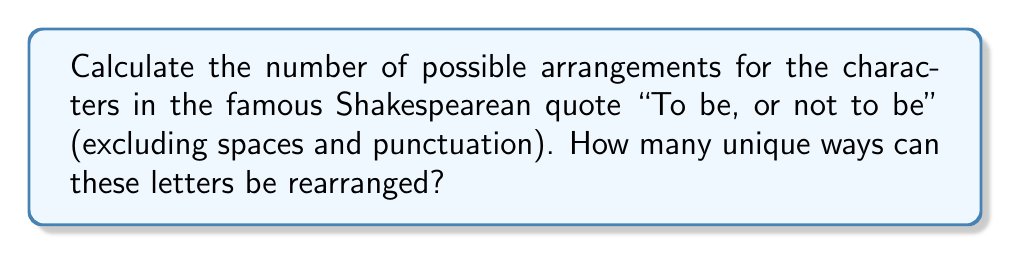Provide a solution to this math problem. Let's approach this step-by-step:

1. First, we need to count the number of each letter in the quote:
   t: 2, o: 2, b: 2, e: 1, r: 1, n: 1

2. The total number of letters is 9.

3. If all letters were different, we would have 9! arrangements. However, we have repeated letters, so we need to account for these.

4. For each set of repeated letters, we divide by the factorial of the number of repetitions. This is because the arrangements of these repeated letters among themselves don't create a new overall arrangement.

5. Therefore, the formula for the number of arrangements is:

   $$\frac{9!}{2! \cdot 2! \cdot 2!}$$

6. Let's calculate this:
   $$\frac{9!}{2! \cdot 2! \cdot 2!} = \frac{362880}{8} = 45360$$

Thus, there are 45,360 possible arrangements of these letters.
Answer: 45,360 